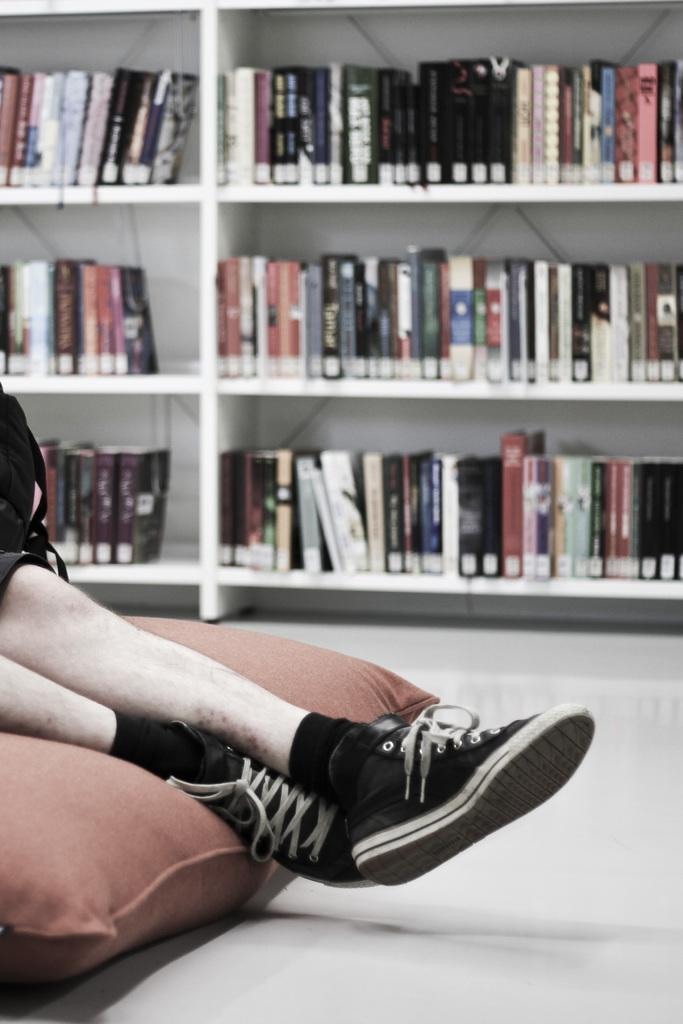What is visible in the foreground of the picture? There are legs of a person in the foreground of the picture. What is the legs resting on? The legs are on a pillow. What can be seen in the background of the picture? There are books in the background of the picture. Where are the books located? The books are in a bookshelf. What type of hook can be seen holding the books in the image? There is no hook present in the image; the books are in a bookshelf. What kind of waves can be seen in the background of the image? There are no waves visible in the image; the background features a bookshelf with books. 